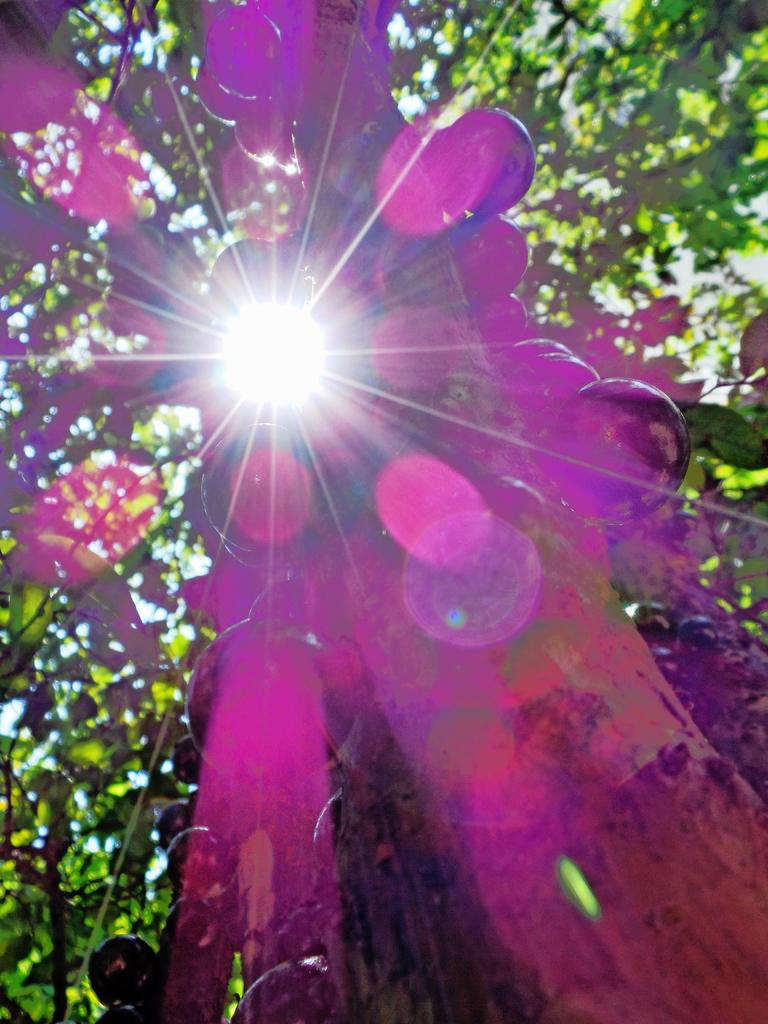What is located in the foreground of the picture? There are fruits in the foreground of the picture. What can be seen in the background of the picture? There are leaves and stems of a tree in the background. What is the condition of the sky in the middle of the picture? The sun is shining in the sky in the middle of the picture. Where is the suit located in the picture? There is no suit present in the picture. Is there a veil visible in the picture? No, there is no veil present in the picture. 